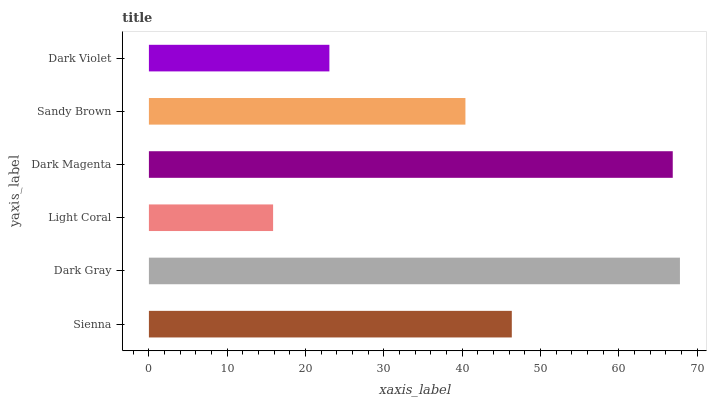Is Light Coral the minimum?
Answer yes or no. Yes. Is Dark Gray the maximum?
Answer yes or no. Yes. Is Dark Gray the minimum?
Answer yes or no. No. Is Light Coral the maximum?
Answer yes or no. No. Is Dark Gray greater than Light Coral?
Answer yes or no. Yes. Is Light Coral less than Dark Gray?
Answer yes or no. Yes. Is Light Coral greater than Dark Gray?
Answer yes or no. No. Is Dark Gray less than Light Coral?
Answer yes or no. No. Is Sienna the high median?
Answer yes or no. Yes. Is Sandy Brown the low median?
Answer yes or no. Yes. Is Dark Gray the high median?
Answer yes or no. No. Is Light Coral the low median?
Answer yes or no. No. 